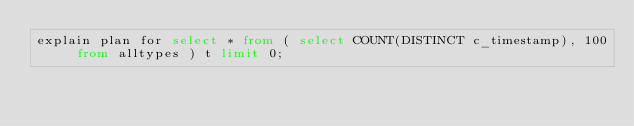<code> <loc_0><loc_0><loc_500><loc_500><_SQL_>explain plan for select * from ( select COUNT(DISTINCT c_timestamp), 100 from alltypes ) t limit 0;
</code> 